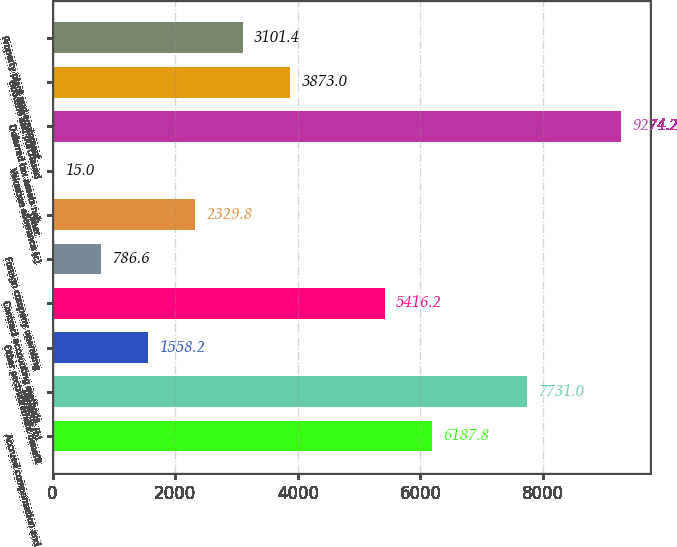Convert chart. <chart><loc_0><loc_0><loc_500><loc_500><bar_chart><fcel>Accrued compensation and<fcel>Pensions (b)<fcel>Other postretirement benefit<fcel>Contract accounting methods<fcel>Foreign company operating<fcel>Other<fcel>Valuation allowance (c)<fcel>Deferred tax assets net<fcel>Goodwill and purchased<fcel>Property plant and equipment<nl><fcel>6187.8<fcel>7731<fcel>1558.2<fcel>5416.2<fcel>786.6<fcel>2329.8<fcel>15<fcel>9274.2<fcel>3873<fcel>3101.4<nl></chart> 